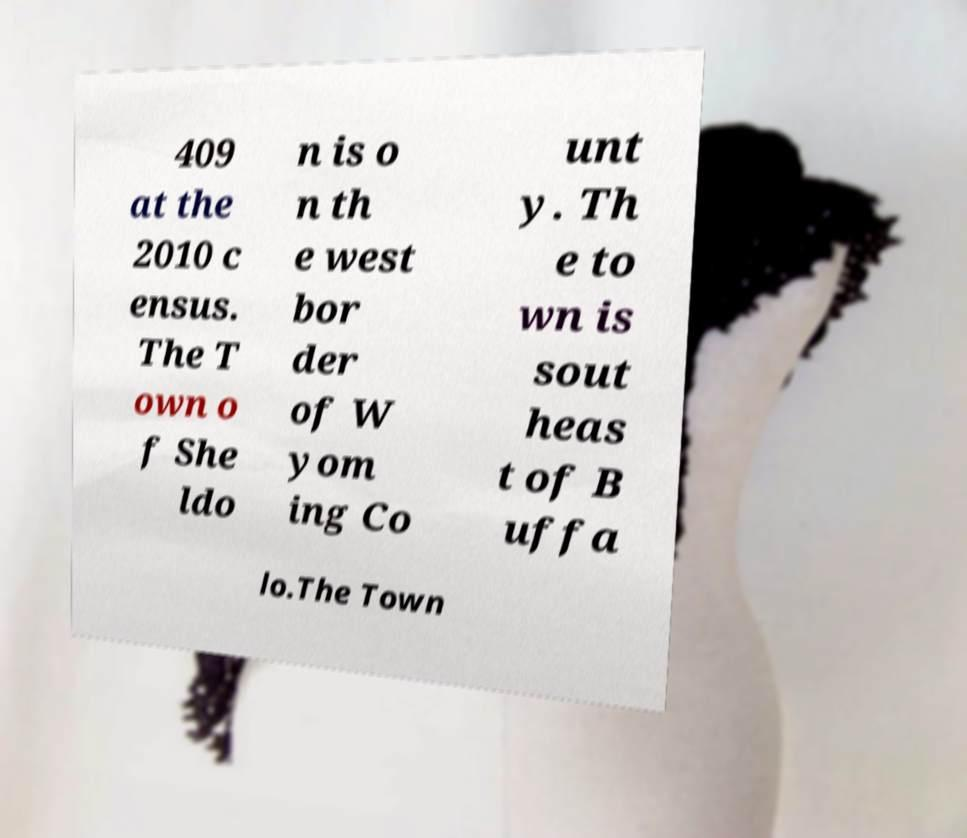Can you accurately transcribe the text from the provided image for me? 409 at the 2010 c ensus. The T own o f She ldo n is o n th e west bor der of W yom ing Co unt y. Th e to wn is sout heas t of B uffa lo.The Town 